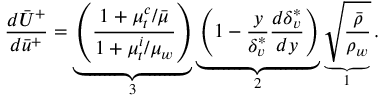Convert formula to latex. <formula><loc_0><loc_0><loc_500><loc_500>\frac { d \bar { U } ^ { + } } { d \bar { u } ^ { + } } = \underbrace { \left ( \frac { 1 + \mu _ { t } ^ { c } / \ B a r { \mu } } { 1 + \mu _ { t } ^ { i } / \mu _ { w } } \right ) } _ { 3 } \underbrace { \left ( { 1 - \frac { y } { \delta _ { v } ^ { * } } \frac { d \delta _ { v } ^ { * } } { d y } } \right ) } _ { 2 } \underbrace { { \sqrt { \frac { \bar { \rho } } { \rho _ { w } } } } } _ { 1 } .</formula> 